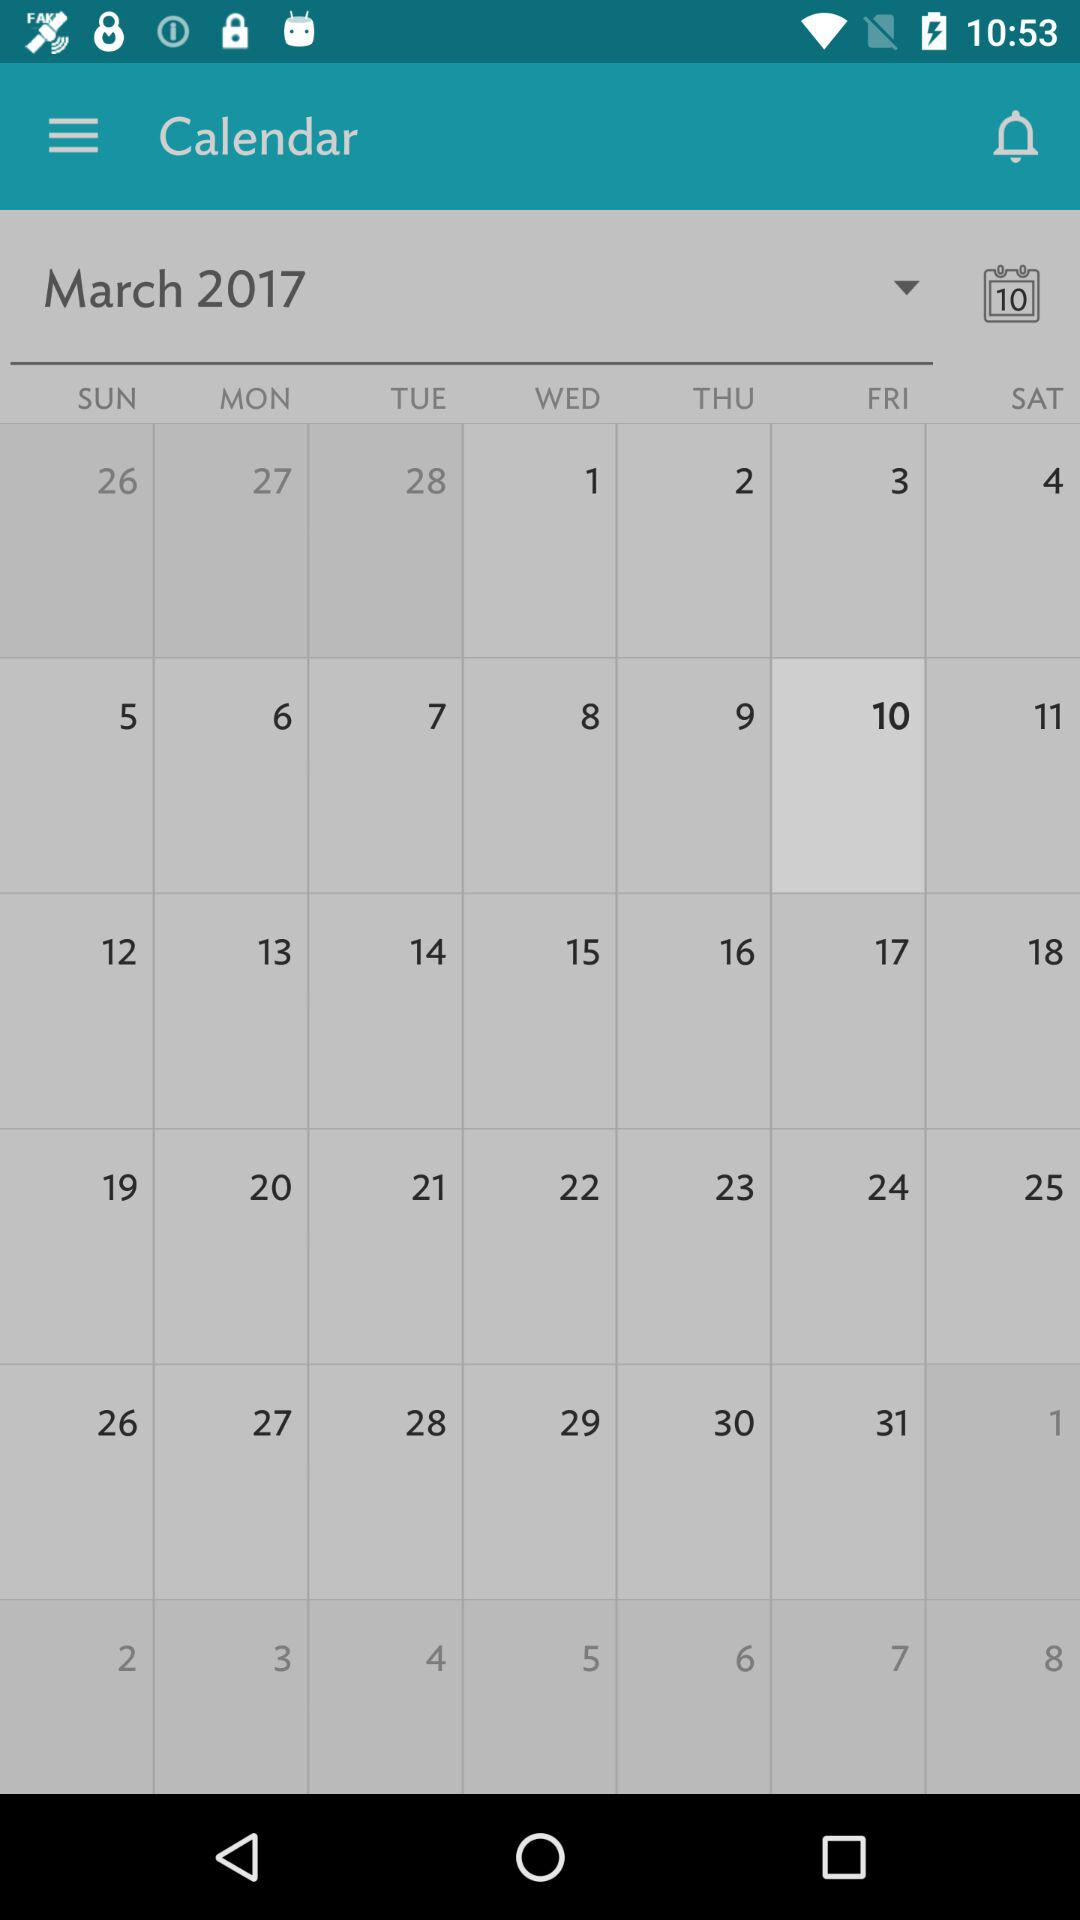What is the day on March 22? The day is Wednesday. 